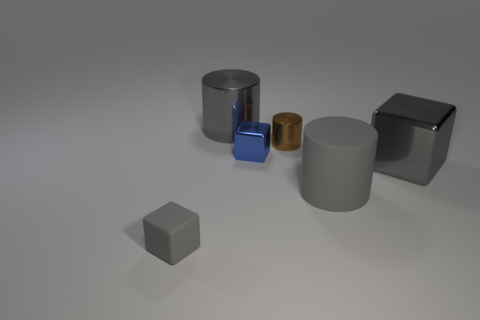Add 2 tiny red metal cylinders. How many objects exist? 8 Subtract all gray rubber blocks. How many blocks are left? 2 Subtract all gray cubes. How many cubes are left? 1 Subtract 1 blocks. How many blocks are left? 2 Subtract 0 red cubes. How many objects are left? 6 Subtract all red cylinders. Subtract all green cubes. How many cylinders are left? 3 Subtract all cyan blocks. How many green cylinders are left? 0 Subtract all small gray rubber spheres. Subtract all large gray metallic things. How many objects are left? 4 Add 6 tiny blue shiny cubes. How many tiny blue shiny cubes are left? 7 Add 6 small yellow shiny things. How many small yellow shiny things exist? 6 